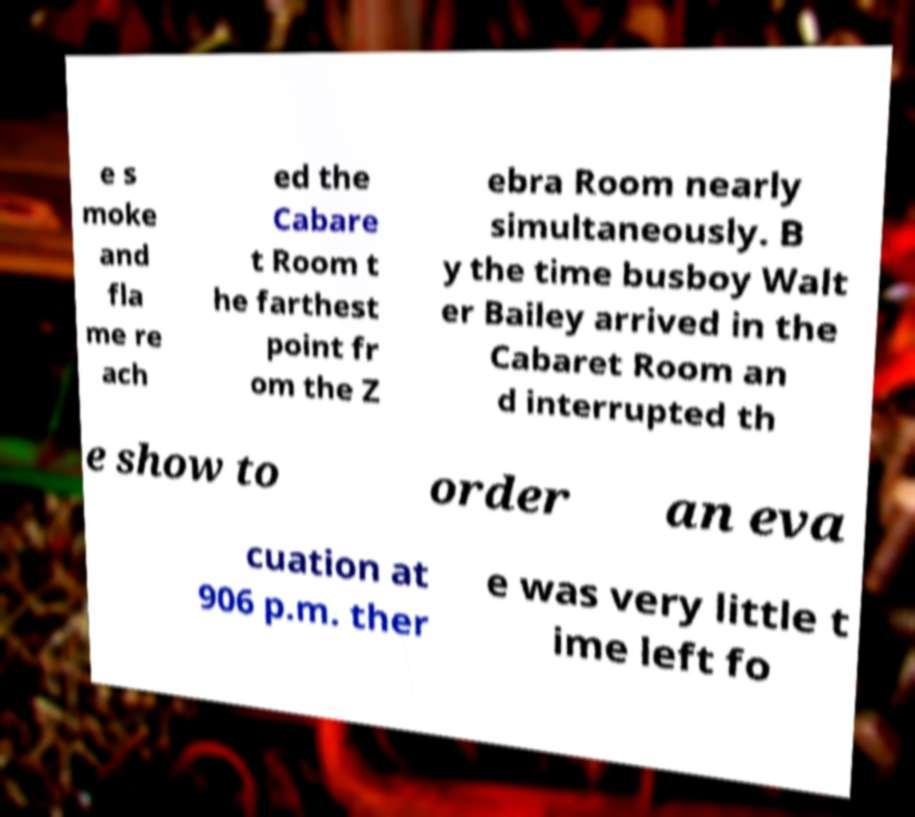I need the written content from this picture converted into text. Can you do that? e s moke and fla me re ach ed the Cabare t Room t he farthest point fr om the Z ebra Room nearly simultaneously. B y the time busboy Walt er Bailey arrived in the Cabaret Room an d interrupted th e show to order an eva cuation at 906 p.m. ther e was very little t ime left fo 